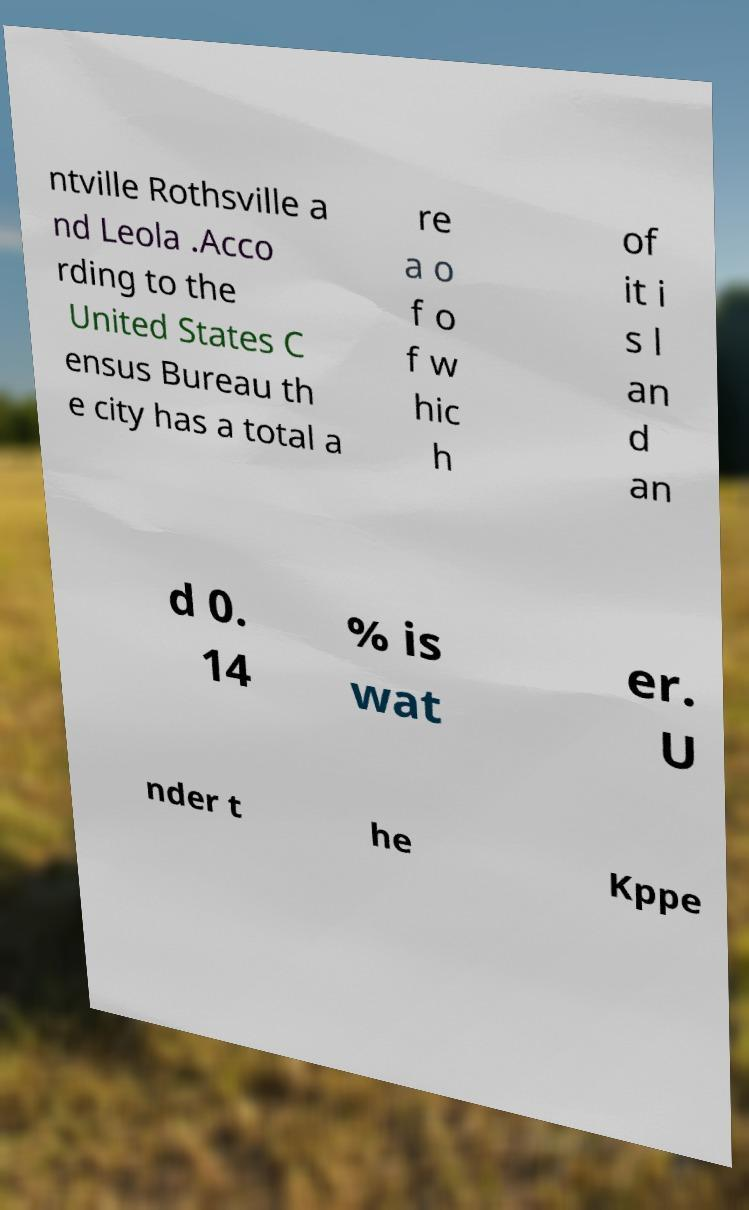Can you read and provide the text displayed in the image?This photo seems to have some interesting text. Can you extract and type it out for me? ntville Rothsville a nd Leola .Acco rding to the United States C ensus Bureau th e city has a total a re a o f o f w hic h of it i s l an d an d 0. 14 % is wat er. U nder t he Kppe 